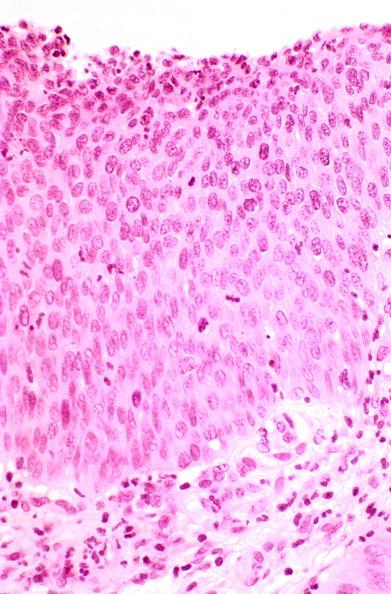what does this image show?
Answer the question using a single word or phrase. Cervix 